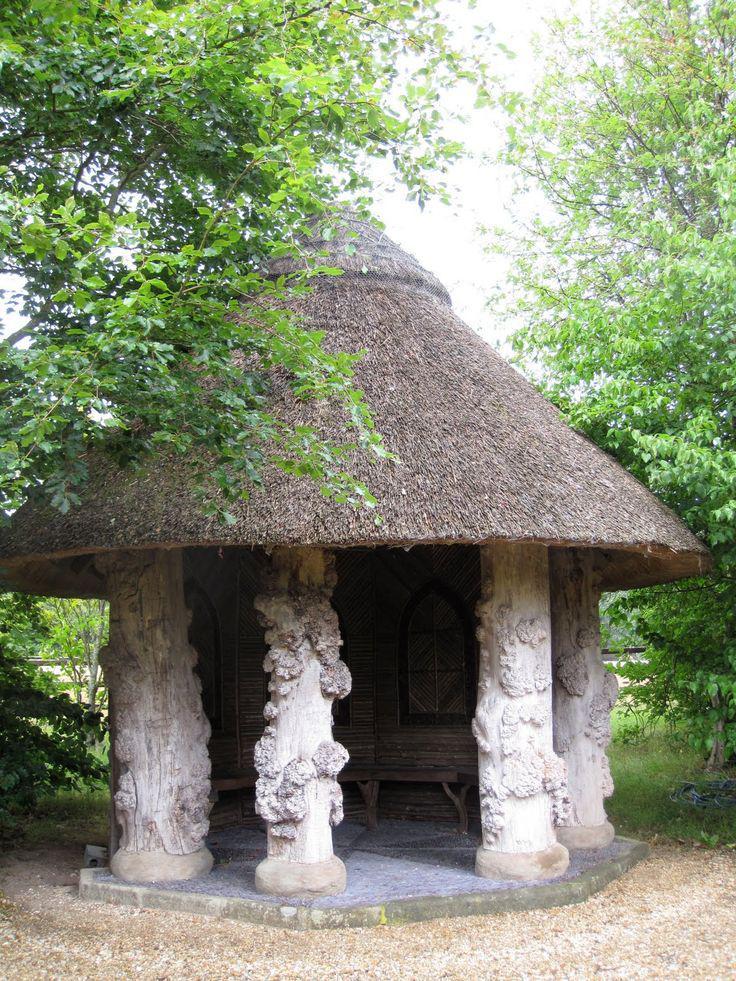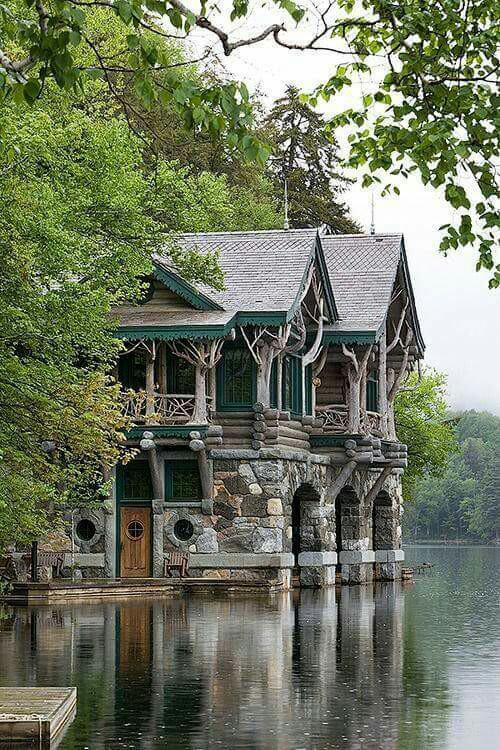The first image is the image on the left, the second image is the image on the right. Evaluate the accuracy of this statement regarding the images: "On image shows stairs ascending rightward to a deck on an elevated structure with a peaked pyramid-shaped roof.". Is it true? Answer yes or no. No. The first image is the image on the left, the second image is the image on the right. Analyze the images presented: Is the assertion "An outdoor ladder leads up to a structure in one of the images." valid? Answer yes or no. No. 